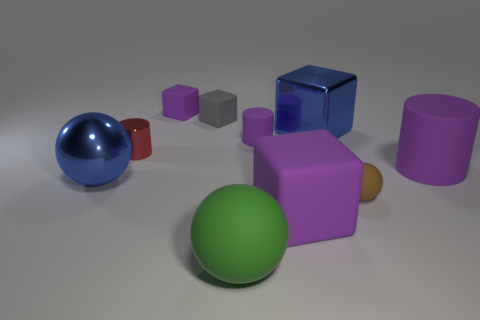Subtract all metal blocks. How many blocks are left? 3 Subtract all cylinders. How many objects are left? 7 Subtract all purple cubes. Subtract all green cylinders. How many cubes are left? 2 Subtract all blue spheres. How many red cylinders are left? 1 Subtract all large spheres. Subtract all red cylinders. How many objects are left? 7 Add 3 big matte spheres. How many big matte spheres are left? 4 Add 1 big blue spheres. How many big blue spheres exist? 2 Subtract all purple cylinders. How many cylinders are left? 1 Subtract 0 red balls. How many objects are left? 10 Subtract 2 cylinders. How many cylinders are left? 1 